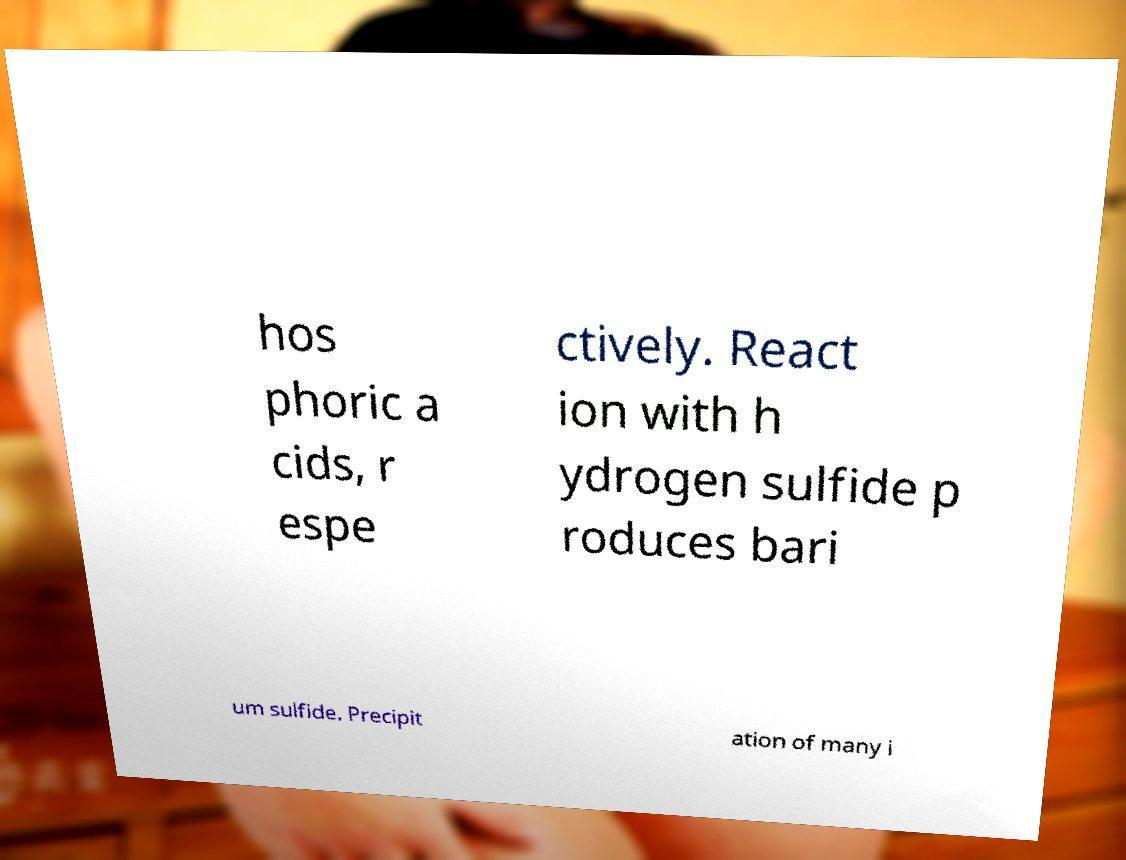Could you assist in decoding the text presented in this image and type it out clearly? hos phoric a cids, r espe ctively. React ion with h ydrogen sulfide p roduces bari um sulfide. Precipit ation of many i 